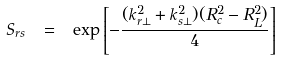Convert formula to latex. <formula><loc_0><loc_0><loc_500><loc_500>S _ { r s } \ = \ \exp \left [ - \frac { ( { k } _ { r \perp } ^ { 2 } + { k } _ { s \perp } ^ { 2 } ) ( R ^ { 2 } _ { c } - R ^ { 2 } _ { L } ) } { 4 } \right ]</formula> 